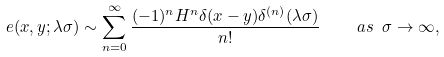<formula> <loc_0><loc_0><loc_500><loc_500>e ( x , y ; \lambda \sigma ) \sim \sum _ { n = 0 } ^ { \infty } \frac { ( - 1 ) ^ { n } H ^ { n } \delta ( x - y ) \delta ^ { ( n ) } ( \lambda \sigma ) } { n ! } \quad a s \ \sigma \rightarrow \infty ,</formula> 